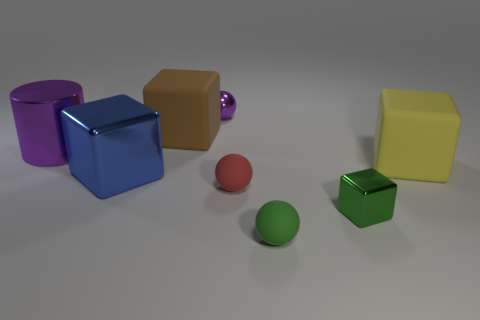Is there a large brown matte block?
Give a very brief answer. Yes. Are there more tiny balls left of the big purple metallic cylinder than red rubber objects that are behind the brown object?
Keep it short and to the point. No. There is a red sphere that is made of the same material as the brown object; what is its size?
Make the answer very short. Small. There is a shiny object that is behind the purple thing that is in front of the tiny metal thing behind the large purple metal object; what is its size?
Make the answer very short. Small. There is a small metallic thing to the right of the small green rubber object; what color is it?
Your response must be concise. Green. Is the number of red matte balls behind the large yellow rubber cube greater than the number of big blue cubes?
Your answer should be compact. No. Do the purple metallic thing that is behind the large cylinder and the tiny red matte thing have the same shape?
Ensure brevity in your answer.  Yes. What number of cyan things are matte spheres or large cylinders?
Provide a succinct answer. 0. Are there more green matte things than red metal cylinders?
Make the answer very short. Yes. What is the color of the metallic thing that is the same size as the purple shiny cylinder?
Your answer should be compact. Blue. 